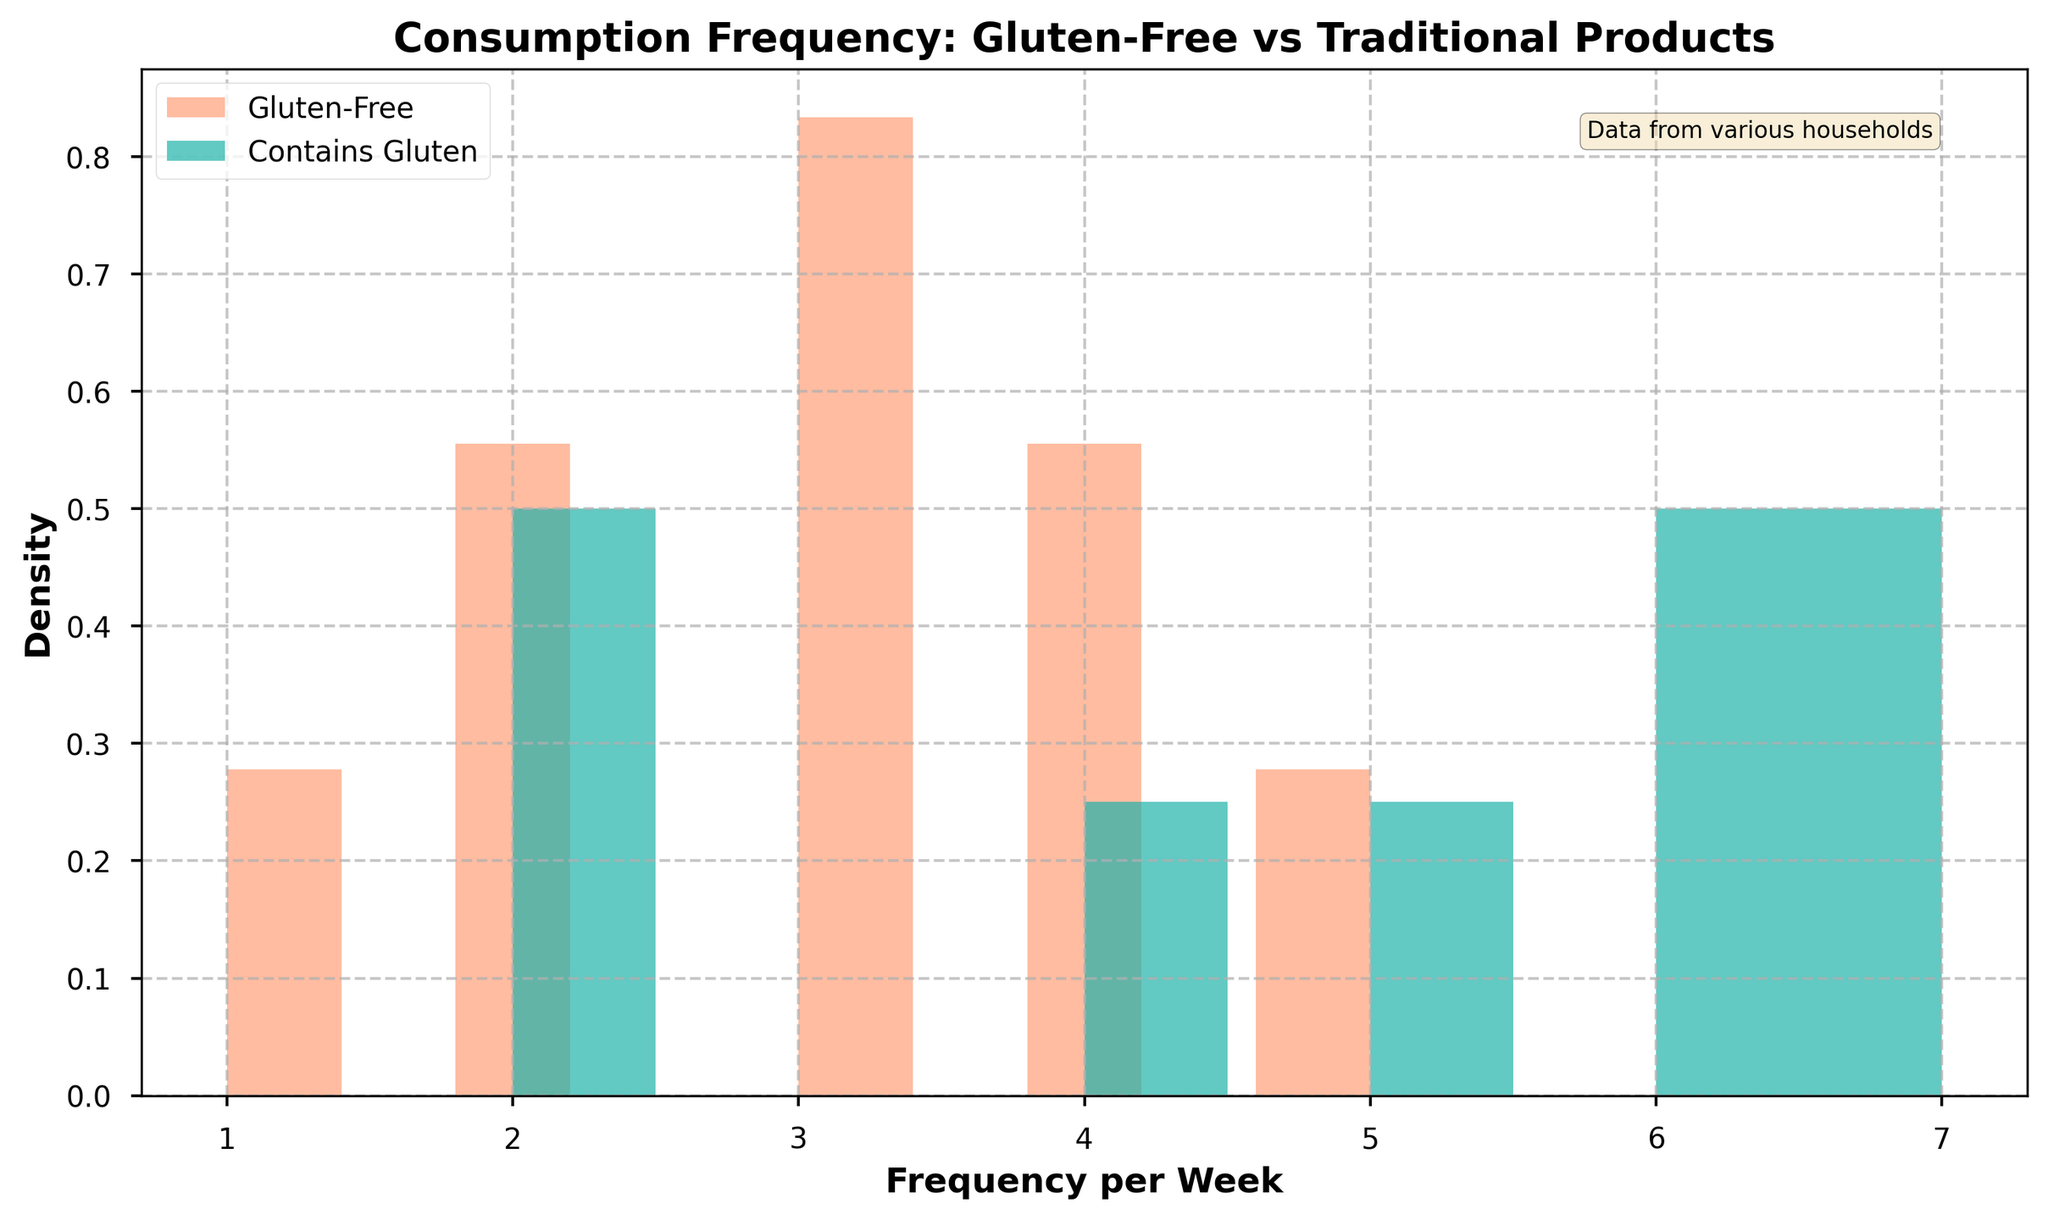How many different types of products are represented in the figure? Look for the products listed in the data. Each unique product name indicates a different type.
Answer: 8 What is the title of the figure? The title is usually located at the top of the plot. Read it directly.
Answer: Consumption Frequency: Gluten-Free vs Traditional Products Which group has a higher density peak, gluten-free or traditional gluten-containing products? Observe the two histograms. The one with the higher peak value represents the group with a higher density peak.
Answer: Gluten-Free What is the general frequency range for gluten-free products consumption? Look at the histogram for gluten-free products. Note the range where the bars have non-zero height.
Answer: 1 to 5 How do the frequencies of traditional gluten-containing products compare to gluten-free products? Compare the position and spread of the histogram bars for both gluten-free and traditional products.
Answer: Traditional products tend to be consumed more frequently per week What colors are used to represent gluten-free and traditional gluten-containing products in the figure? Identify the colors of the plotted histograms, as indicated in the legend.
Answer: Gluten-Free: Light Coral, Contains Gluten: Light Sea Green On average, which type of product is consumed more frequently per week, gluten-free or traditional gluten-containing? Look at the distribution of each histogram. Typical higher peaks and more frequent values will indicate the average consumption.
Answer: Traditional Gluten-Containing Considering the figure, which type of product would you say shows a more varied consumption pattern? Observe the width of the histograms for each type. A wider spread indicates more variation.
Answer: Gluten-Free Which household consumes bread more frequently, Smith Household or Johnson Household? Review the data to see the frequency values for 'Bread' in both Smith and Johnson Households.
Answer: Johnson Household What additional information is provided in the text box on the figure? Read the text inside the small box typically placed within the plot area.
Answer: Data from various households 